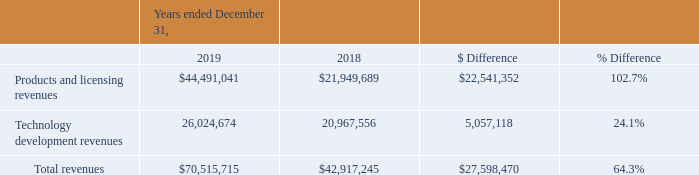Year Ended December 31, 2019 Compared to Year Ended December 31, 2018
Revenues
Our Products and Licensing segment included revenues from sales of test and measurement systems, primarily representing sales of our Optical Backscatter Reflectometer, ODiSI, and Optical Vector Analyzer platforms, optical components and sub-assemblies and sales of our Hyperion and Terahertz sensing platforms. Our Products and Licensing segment revenues increased $22.5 million to $44.5 million for the year ended December 31, 2019 compared to $21.9 million for the year ended December 31, 2018.
The increase resulted primarily from $10.8 million of revenues realized from the legacy business of MOI and $10.5 million of revenues realized from the legacy business of GP during the year ended December 31, 2019. Continued growth in sales of our fiber-optic sensing products, including our ODiSI products directed toward the expanding use of composite materials and the need for improved means of testing their structural integrity, and our communications test instruments also contributed to this increase.
Our Technology Development segment revenues increased $5.1 million to $26.0 million for the year ended December 31, 2019 compared to $21.0 million for the year ended December 31, 2018. Revenues within this segment increased due to additional contract awards, including higher value Phase 2 SBIR contracts. The increase continues a growth trend experienced over the past two years largely driven by successes in Phase 2 SBIR awards. The increase was realized primarily in our intelligent systems, advanced materials, optical systems and terahertz research groups. As Phase 2 SBIR contracts generally have a performance period of a year or more, we currently expect Technology Development segment revenues to remain at a similar level for the near term.
What led to revenues within Technology Development segment to increase from 2018 to 2019? Due to additional contract awards, including higher value phase 2 sbir contracts. What is the average Products and licensing revenues for December 31, 2018 and 2019? (44,491,041+21,949,689) / 2
Answer: 33220365. What is the average Technology development revenues for December 31, 2018 and 2019? (26,024,674+20,967,556) / 2
Answer: 23496115. In which year was Products and licensing revenues less than 40,000,000? Locate and analyze products and licensing revenues in row 3
answer: 2018. What was the increase in the Products and Licensing segment revenue in 2019? $22.5 million. What was the Technology development revenues in 2019 and 2018 respectively?
Answer scale should be: million. 26,024,674, 20,967,556. 